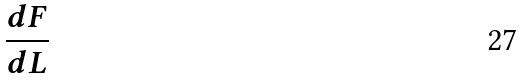<formula> <loc_0><loc_0><loc_500><loc_500>\frac { d F } { d L }</formula> 